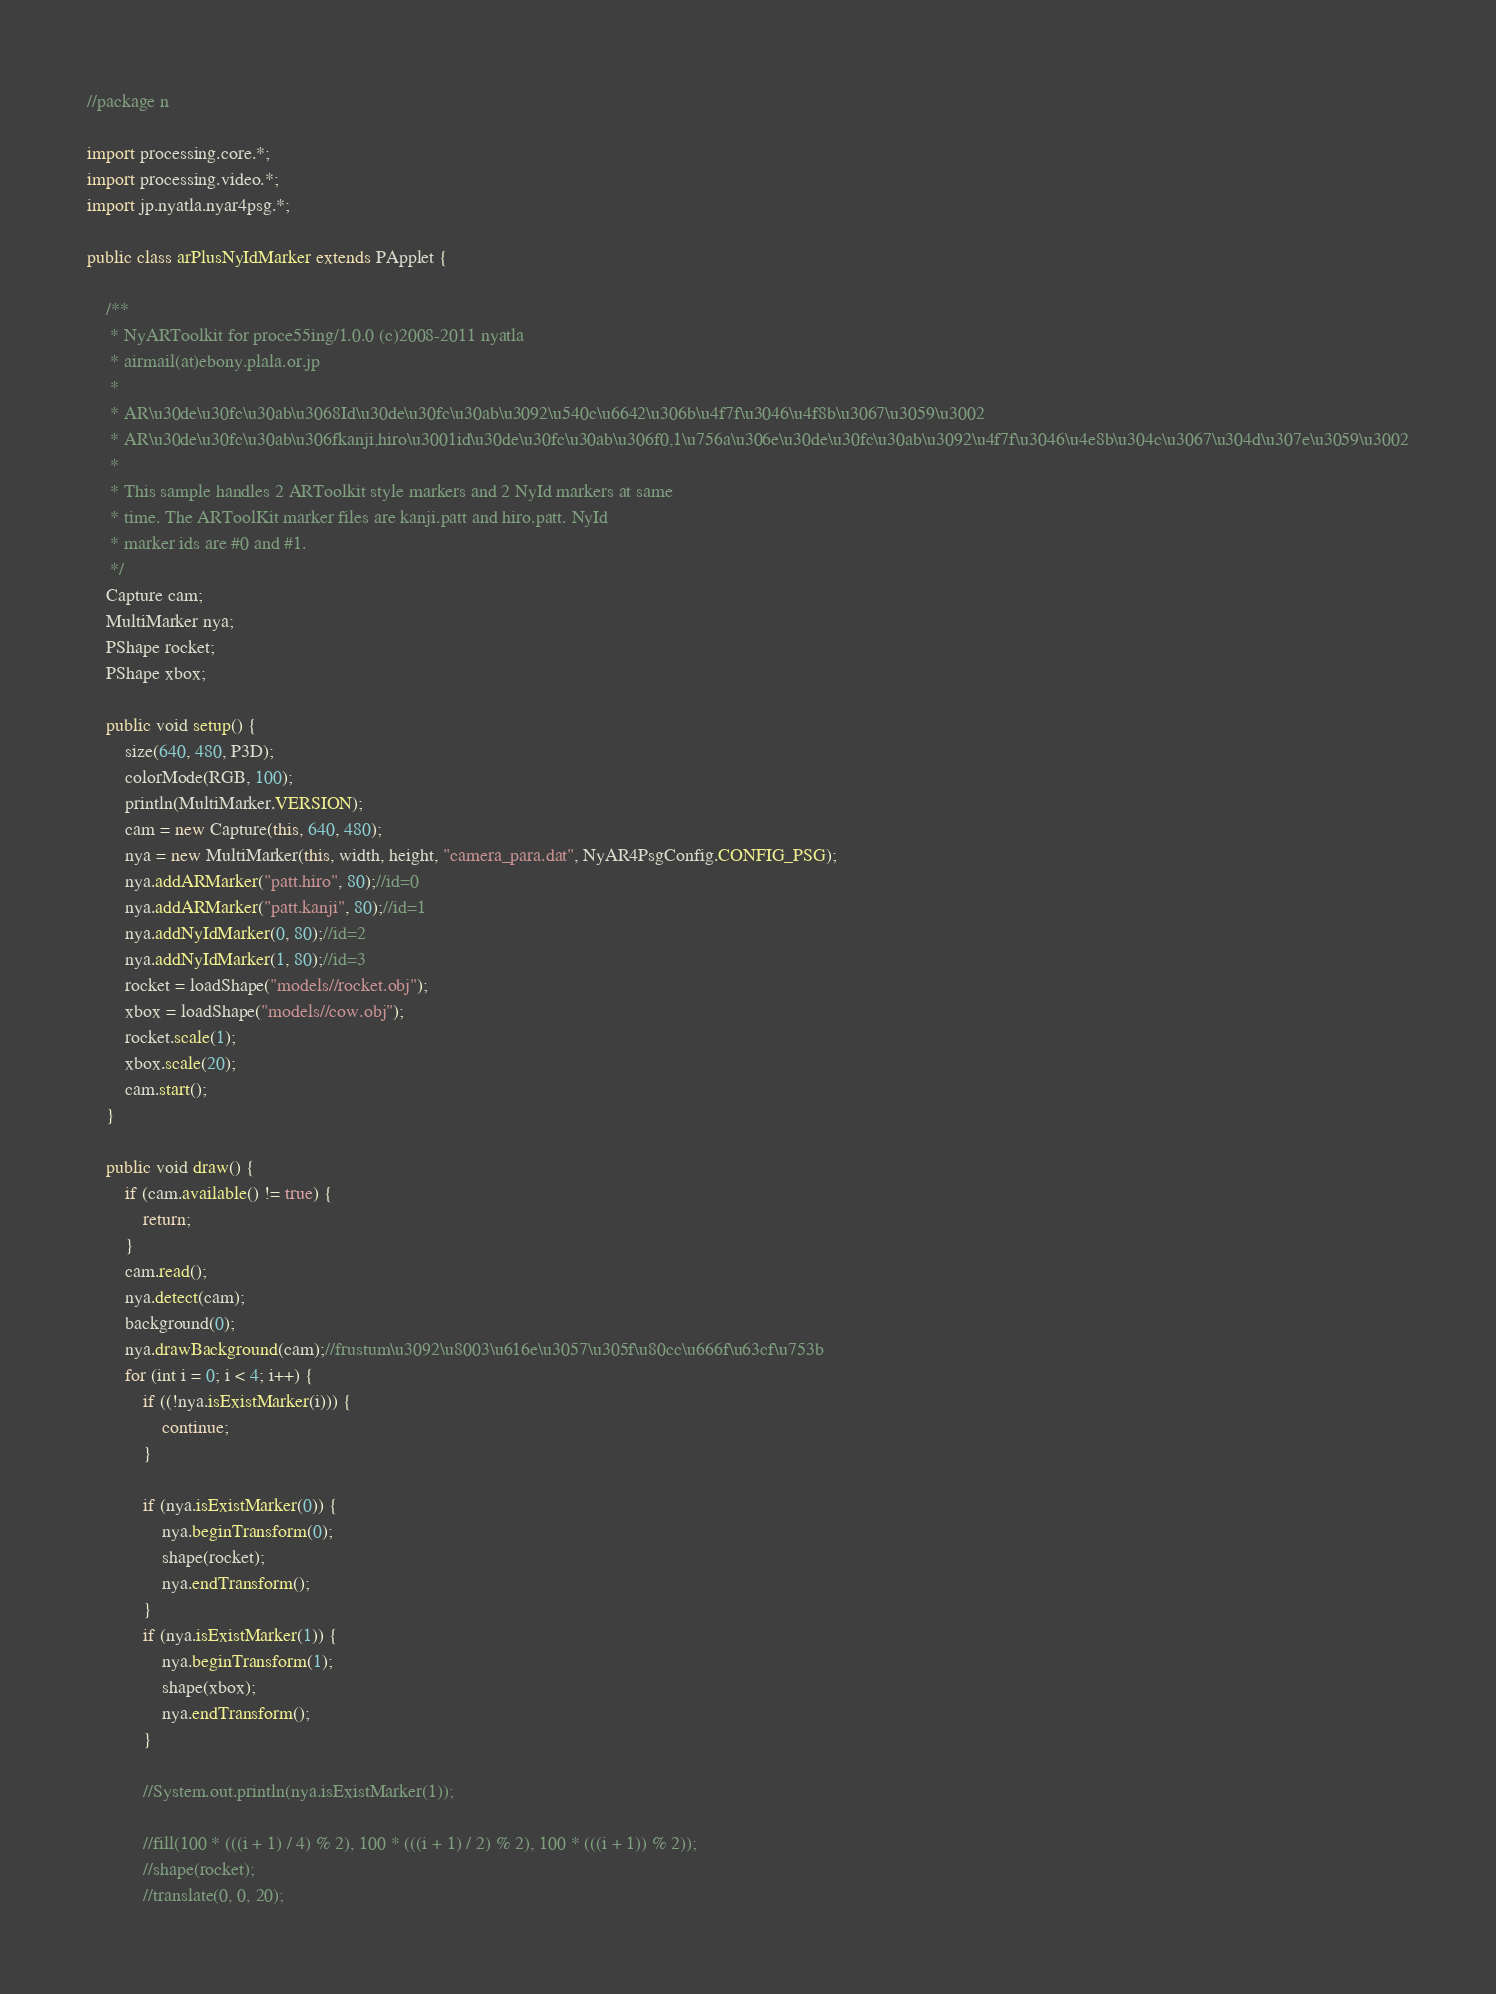<code> <loc_0><loc_0><loc_500><loc_500><_Java_>//package n

import processing.core.*;
import processing.video.*;
import jp.nyatla.nyar4psg.*;

public class arPlusNyIdMarker extends PApplet {

    /**
     * NyARToolkit for proce55ing/1.0.0 (c)2008-2011 nyatla
     * airmail(at)ebony.plala.or.jp
     *
     * AR\u30de\u30fc\u30ab\u3068Id\u30de\u30fc\u30ab\u3092\u540c\u6642\u306b\u4f7f\u3046\u4f8b\u3067\u3059\u3002
     * AR\u30de\u30fc\u30ab\u306fkanji,hiro\u3001id\u30de\u30fc\u30ab\u306f0,1\u756a\u306e\u30de\u30fc\u30ab\u3092\u4f7f\u3046\u4e8b\u304c\u3067\u304d\u307e\u3059\u3002
     *
     * This sample handles 2 ARToolkit style markers and 2 NyId markers at same
     * time. The ARToolKit marker files are kanji.patt and hiro.patt. NyId
     * marker ids are #0 and #1.
     */
    Capture cam;
    MultiMarker nya;
    PShape rocket;
    PShape xbox;

    public void setup() {
        size(640, 480, P3D);
        colorMode(RGB, 100);
        println(MultiMarker.VERSION);
        cam = new Capture(this, 640, 480);
        nya = new MultiMarker(this, width, height, "camera_para.dat", NyAR4PsgConfig.CONFIG_PSG);
        nya.addARMarker("patt.hiro", 80);//id=0
        nya.addARMarker("patt.kanji", 80);//id=1
        nya.addNyIdMarker(0, 80);//id=2
        nya.addNyIdMarker(1, 80);//id=3
        rocket = loadShape("models//rocket.obj");
        xbox = loadShape("models//cow.obj");
        rocket.scale(1);
        xbox.scale(20);
        cam.start();
    }

    public void draw() {
        if (cam.available() != true) {
            return;
        }
        cam.read();
        nya.detect(cam);
        background(0);
        nya.drawBackground(cam);//frustum\u3092\u8003\u616e\u3057\u305f\u80cc\u666f\u63cf\u753b
        for (int i = 0; i < 4; i++) {
            if ((!nya.isExistMarker(i))) {
                continue;
            }
            
            if (nya.isExistMarker(0)) {
                nya.beginTransform(0);
                shape(rocket);
                nya.endTransform();
            }
            if (nya.isExistMarker(1)) {
                nya.beginTransform(1);
                shape(xbox);
                nya.endTransform();
            }
            
            //System.out.println(nya.isExistMarker(1));
            
            //fill(100 * (((i + 1) / 4) % 2), 100 * (((i + 1) / 2) % 2), 100 * (((i + 1)) % 2));
            //shape(rocket);
            //translate(0, 0, 20);</code> 